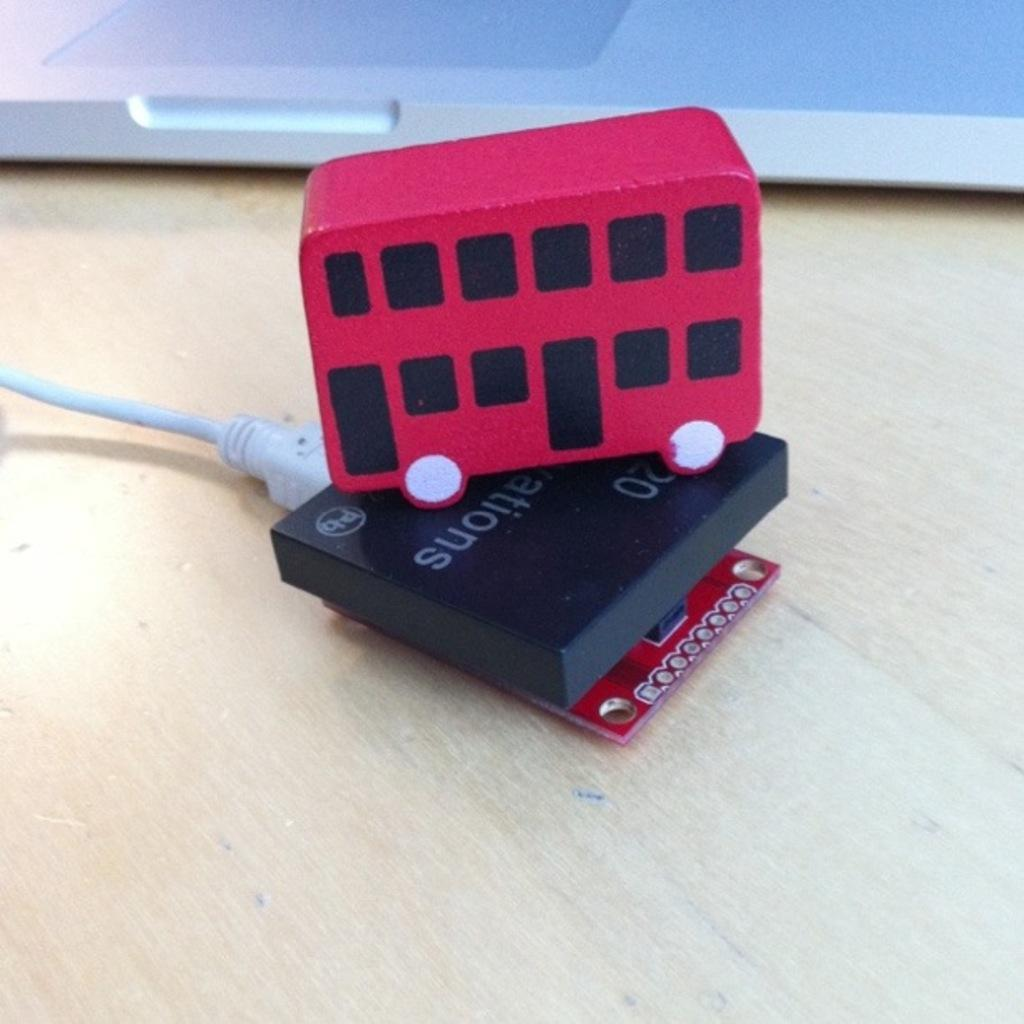What type of toy is in the image? There is a toy bus in the image. What colors are used for the toy bus? The toy bus is red and black in color. Where is the toy bus located? The toy bus is on an electronic gadget. What other electronic device can be seen in the image? There is a laptop on the back side of the image. What type of surface is the electronic gadget and laptop placed on? The wooden table is present in the image. Can you see the mother of the toy bus in the image? There is no mother of the toy bus present in the image, as it is an inanimate object. How many buttons are on the toy bus in the image? There are no buttons visible on the toy bus in the image. 